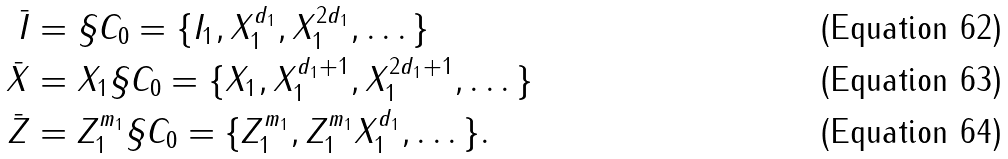<formula> <loc_0><loc_0><loc_500><loc_500>\bar { I } & = \S C _ { 0 } = \{ I _ { 1 } , X _ { 1 } ^ { d _ { 1 } } , X _ { 1 } ^ { 2 d _ { 1 } } , \dots \} \\ \bar { X } & = X _ { 1 } \S C _ { 0 } = \{ X _ { 1 } , X _ { 1 } ^ { d _ { 1 } + 1 } , X _ { 1 } ^ { 2 d _ { 1 } + 1 } , \dots \} \\ \bar { Z } & = Z _ { 1 } ^ { m _ { 1 } } \S C _ { 0 } = \{ Z _ { 1 } ^ { m _ { 1 } } , Z _ { 1 } ^ { m _ { 1 } } X _ { 1 } ^ { d _ { 1 } } , \dots \} .</formula> 